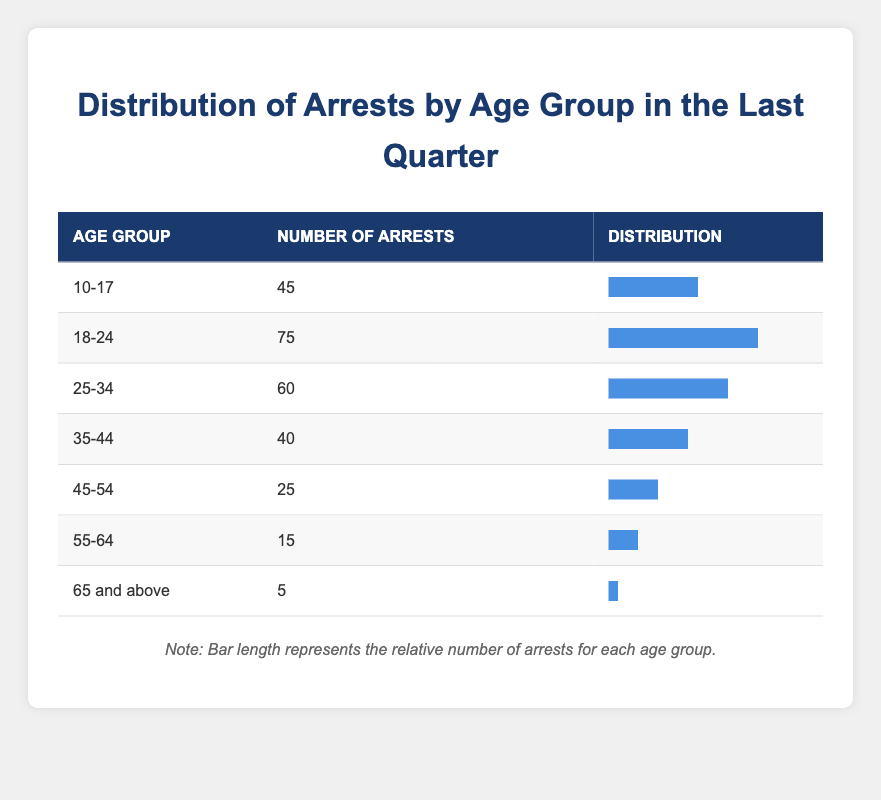What is the age group with the highest number of arrests? The table shows that the age group "18-24" has the highest number of arrests with 75. This is directly observable by comparing the numbers of arrests across all age groups listed.
Answer: 18-24 How many arrests were made in the age group 25-34? The table specifies that there were 60 arrests made within the age group 25-34. This information is clearly stated in the corresponding row of the table.
Answer: 60 What is the total number of arrests for the age groups 10-17 and 35-44? To find the total arrests for the age groups 10-17 and 35-44, we add the number of arrests from those two groups: 45 (10-17) + 40 (35-44) = 85. Therefore, the total number of arrests for these age groups is 85.
Answer: 85 Is it true that more people were arrested in the age group 55-64 than in the age group 65 and above? By comparing the numbers, we see that 15 arrests were made in the age group 55-64 and only 5 in the age group 65 and above. Thus, it is true that more people were arrested in the age group 55-64.
Answer: Yes What age group has the least number of arrests, and how many arrests were made? The age group with the least number of arrests is "65 and above," which had only 5 arrests. This is confirmed by looking at the numbers in the last row of the table, which shows that this group has the fewest arrests compared to all other age groups.
Answer: 65 and above, 5 What is the average number of arrests across all age groups? To find the average, we need to first sum all the arrests: 45 + 75 + 60 + 40 + 25 + 15 + 5 = 265. Then, we count the number of age groups, which is 7. Finally, we divide the total arrests by the number of age groups: 265 / 7 ≈ 37.14. Therefore, the average number of arrests across all age groups is approximately 37.14.
Answer: 37.14 Which age group has a number of arrests greater than the average number of arrests? The average number of arrests is approximately 37.14. By comparing this value with the arrest numbers for each age group, we find that the age groups "18-24" (75), "25-34" (60), and "10-17" (45) have numbers greater than the average.
Answer: 18-24, 25-34, 10-17 